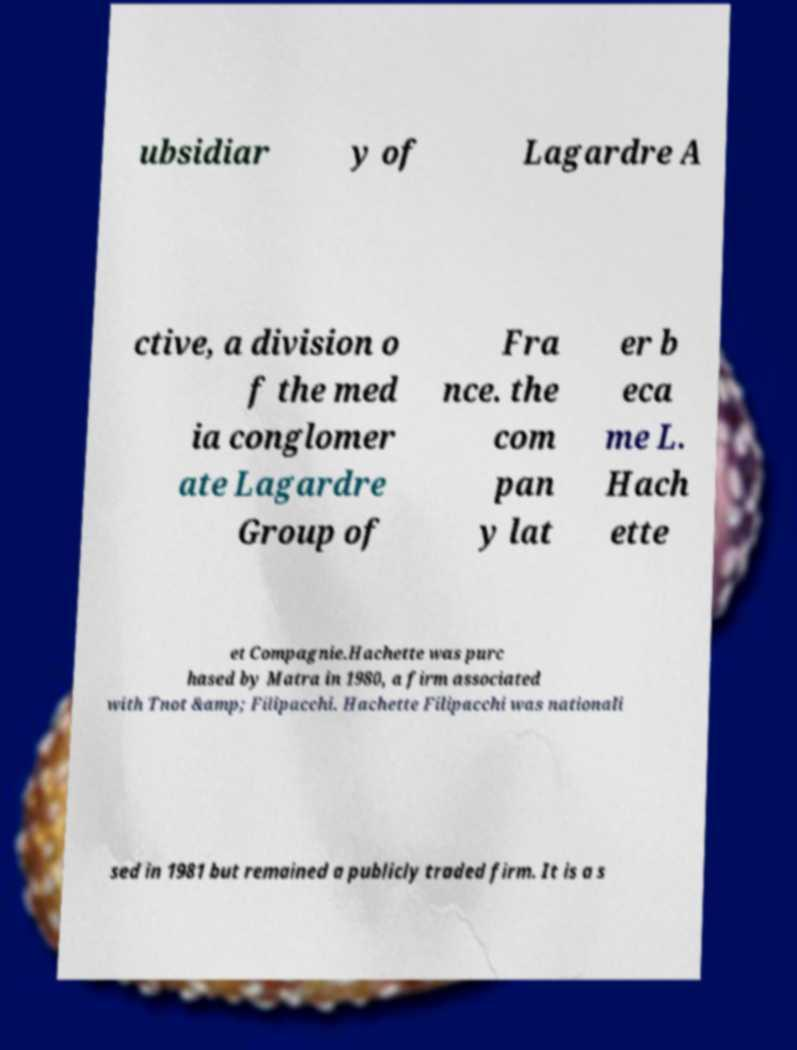Could you assist in decoding the text presented in this image and type it out clearly? ubsidiar y of Lagardre A ctive, a division o f the med ia conglomer ate Lagardre Group of Fra nce. the com pan y lat er b eca me L. Hach ette et Compagnie.Hachette was purc hased by Matra in 1980, a firm associated with Tnot &amp; Filipacchi. Hachette Filipacchi was nationali sed in 1981 but remained a publicly traded firm. It is a s 